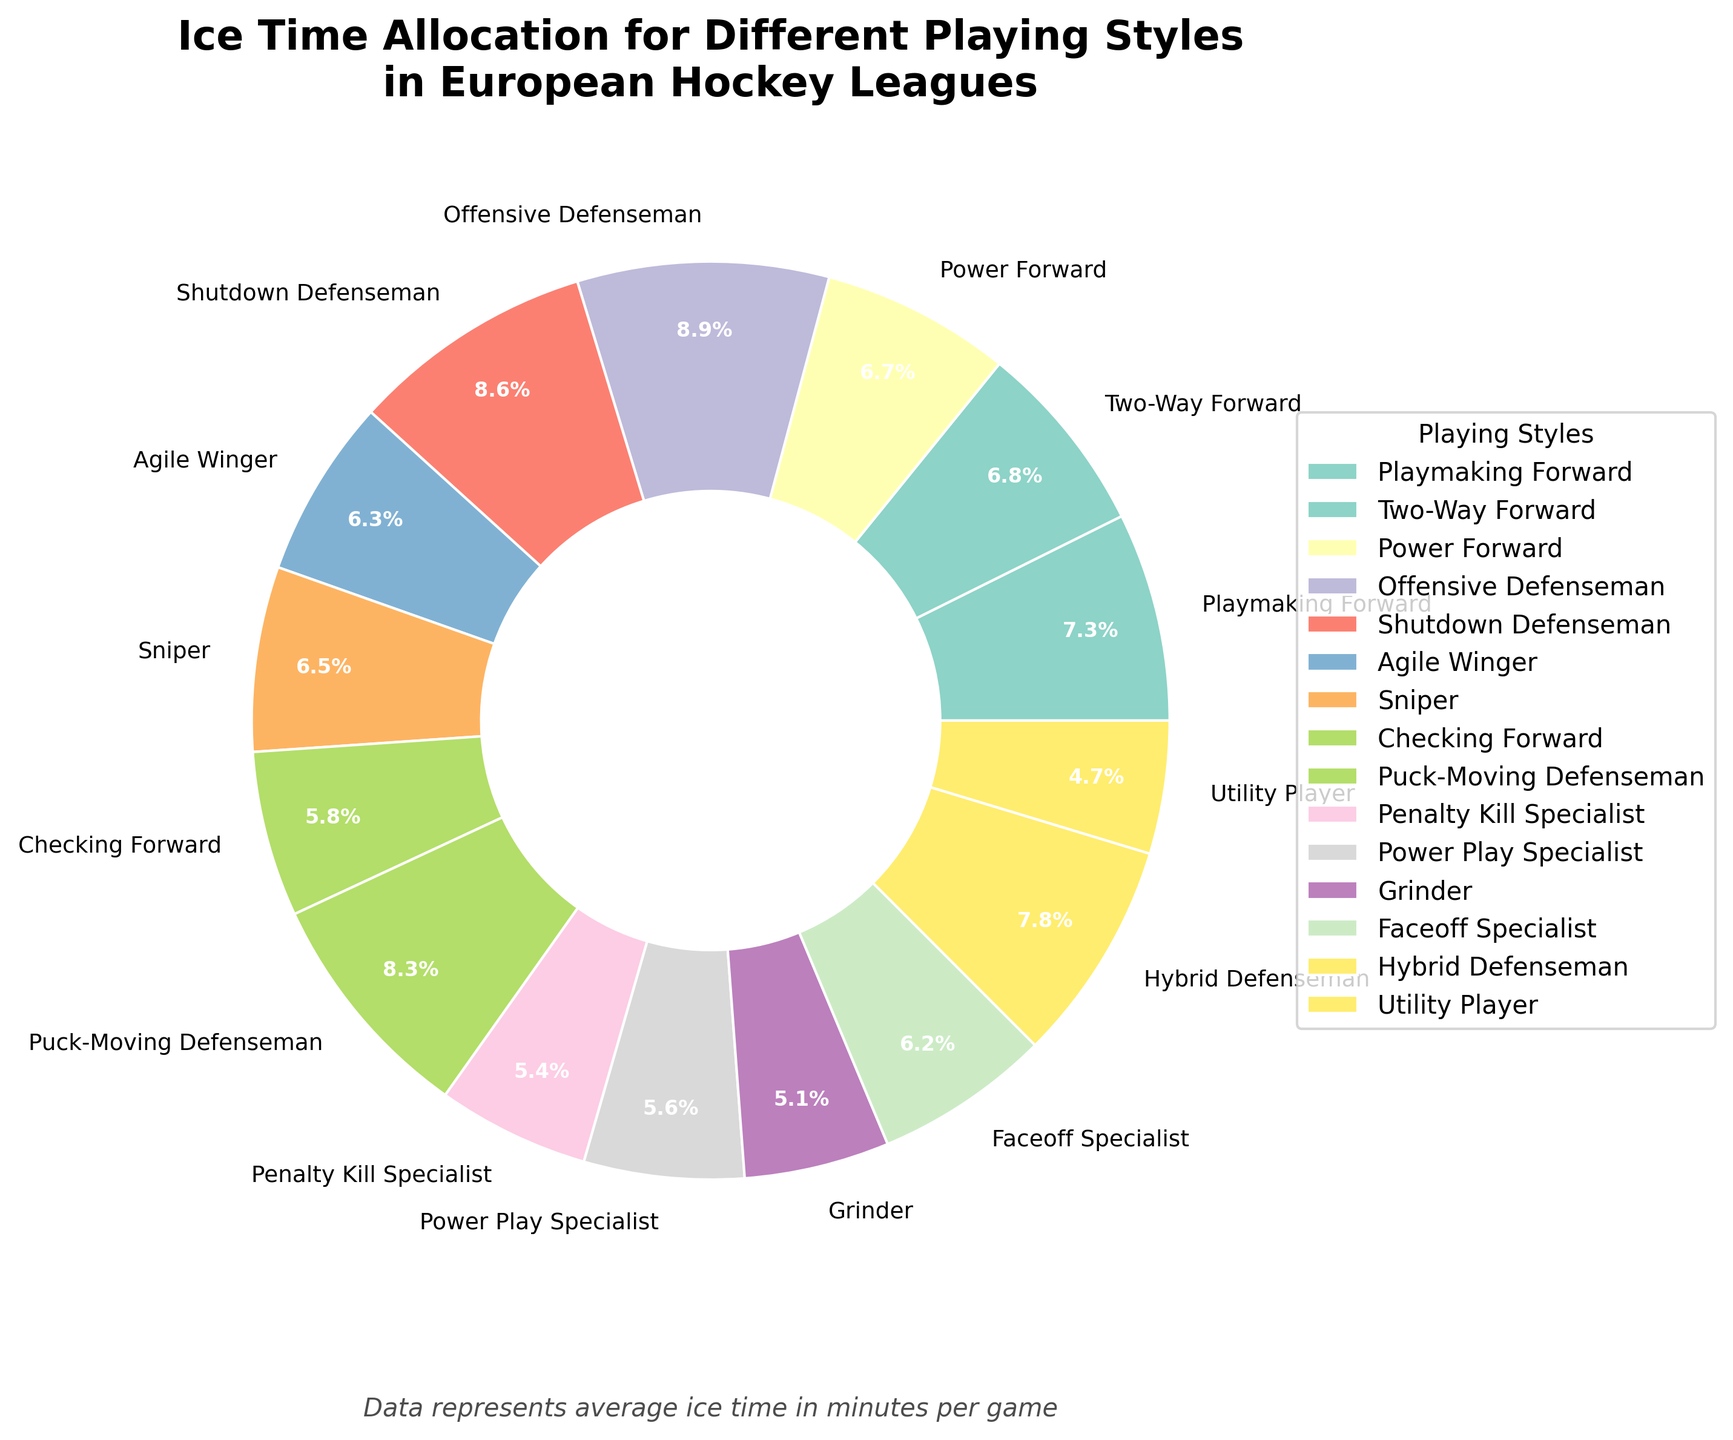Which playing style has the highest average ice time? By visually examining the pie chart, look for the largest segment and its corresponding label. This segment represents the playing style with the highest average ice time.
Answer: Offensive Defenseman What is the combined average ice time for the Power Forward and Sniper playing styles? First, find the segments labeled "Power Forward" and "Sniper" on the pie chart and note their average ice times. Add these two values together.
Answer: 33.2 minutes Which playing style has the least average ice time, and what is it? Look for the smallest segment in the pie chart and read its label to find the playing style with the least average ice time.
Answer: Utility Player, 11.8 minutes How does the average ice time of the Shutdown Defenseman compare to that of the Puck-Moving Defenseman? Find the segments labeled "Shutdown Defenseman" and "Puck-Moving Defenseman" and compare their average ice times.
Answer: Shutdown Defenseman has less ice time than Puck-Moving Defenseman What is the average ice time allocated to midfield playing styles (consider Two-Way Forward, Checking Forward, and Faceoff Specialist)? Identify the segments for Two-Way Forward, Checking Forward, and Faceoff Specialist and note their average ice times. Calculate the average of these three values by summing them up and dividing by three.
Answer: 15.8333 minutes Which segment is displayed in the lightest color, and what is its corresponding playing style? Visually inspect the pie chart for the segment that appears to be in the lightest color shade and read its label.
Answer: Utility Player How much more average ice time does the Agile Winger have compared to the Grinder? Find the segments labeled "Agile Winger" and "Grinder" and note their average ice times. Subtract the Grinder's ice time from the Agile Winger's ice time.
Answer: 3 minutes Which playing styles have an average ice time greater than 20 minutes per game? Identify and list the segments with average ice times above 20 minutes by visually inspecting each label and its value.
Answer: Offensive Defenseman, Shutdown Defenseman, Puck-Moving Defenseman, Hybrid Defenseman What proportion of the total average ice time is allocated to defensive playing styles (consider Offensive Defenseman, Shutdown Defenseman, Puck-Moving Defenseman, Hybrid Defenseman)? Find and sum the ice times for the specified defensive playing styles. Then divide this sum by the total ice time of all styles and multiply by 100 to get the percentage.
Answer: 32.16% 